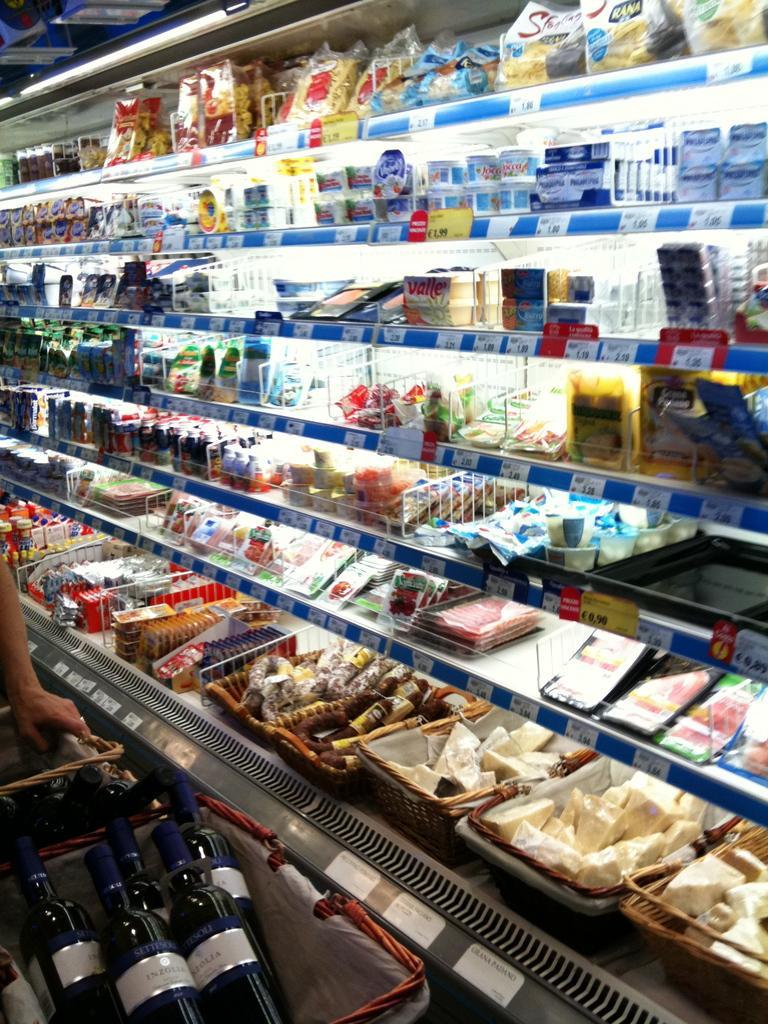Can you describe this image briefly? In this picture there is a inside view of the super market. In front we can see some foodstuffs is placed in the racks. On the bottom side of the rock there is a wooden basket with black color bottles. 